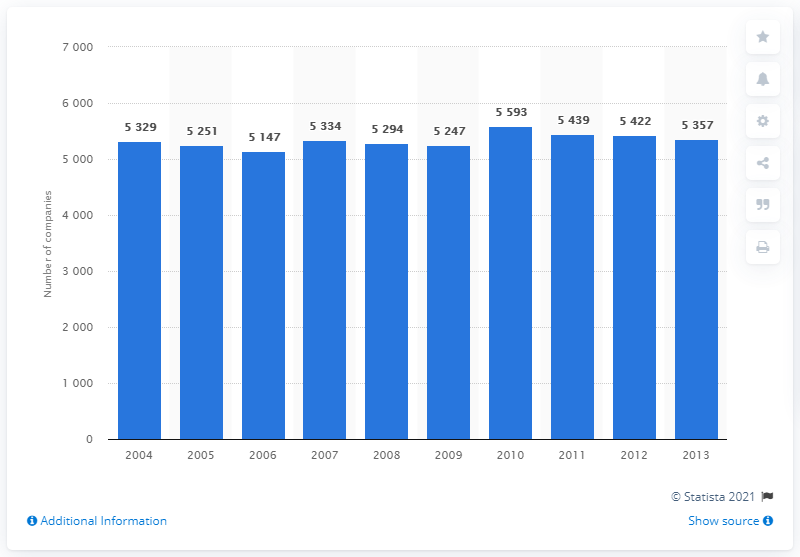How many companies were active in the insurance sector by the end of 2013?
 5357 